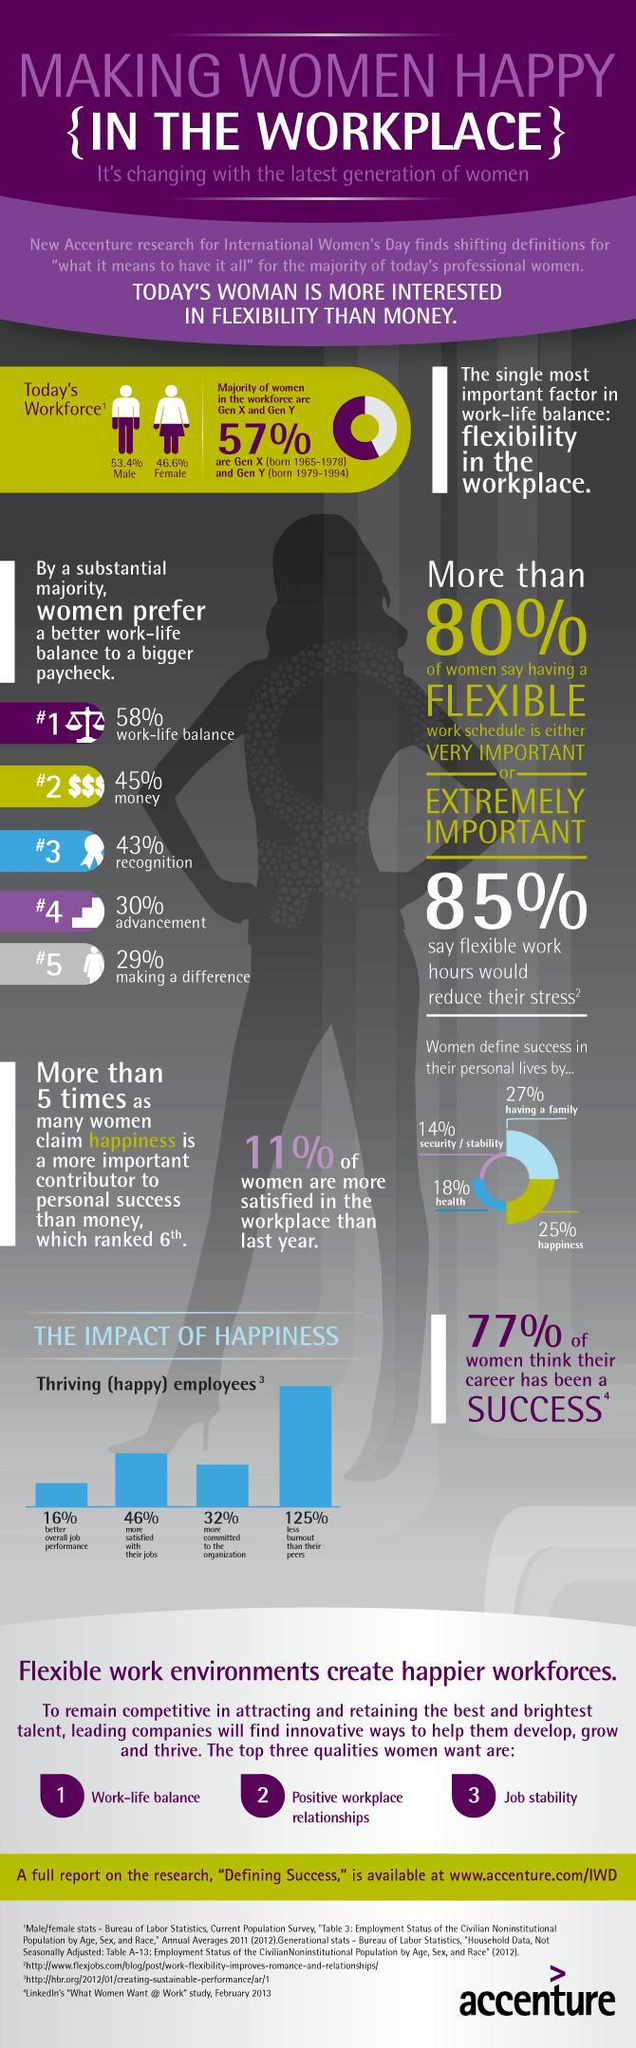What percentile of women feel that being happy defines success, 14%, 18%, or 25%?
Answer the question with a short phrase. 25% What largest indicator of the impact of happiness in relation to jobs, low exhaustion, high commitment, or high satisfaction? low exhaustion 